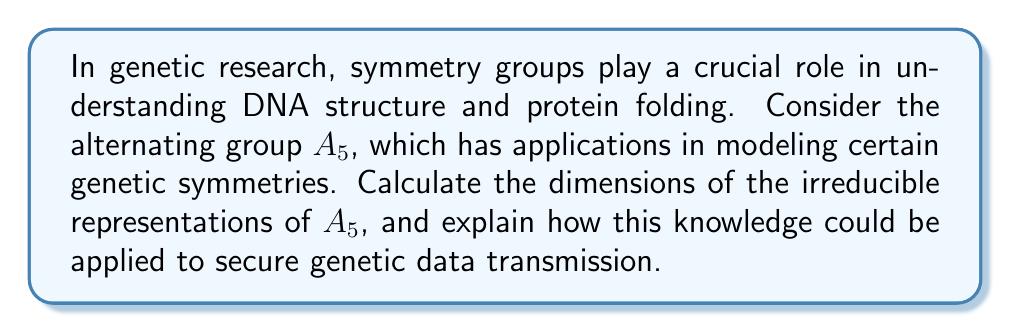Provide a solution to this math problem. To calculate the dimensions of the irreducible representations of $A_5$, we'll follow these steps:

1) First, recall that $A_5$ is the group of even permutations on 5 elements, with order $|A_5| = 60$.

2) The number of conjugacy classes in $A_5$ equals the number of irreducible representations. $A_5$ has 5 conjugacy classes:
   - Identity: $(1)$
   - 15 3-cycles: $(123)$
   - 20 3-cycles: $(132)$
   - 12 5-cycles: $(12345)$
   - 12 5-cycles: $(13524)$

3) Let's denote the dimensions of the irreducible representations as $d_1, d_2, d_3, d_4, d_5$.

4) We know that the sum of squares of dimensions equals the order of the group:

   $$d_1^2 + d_2^2 + d_3^2 + d_4^2 + d_5^2 = 60$$

5) The trivial representation always has dimension 1, so $d_1 = 1$.

6) $A_5$ is a simple group, so it has no non-trivial 1-dimensional representations.

7) The smallest non-trivial representation of $A_5$ has dimension 3 (this can be proved using character theory), so $d_2 = 3$.

8) $A_5$ is isomorphic to the group of rotational symmetries of an icosahedron, which has a natural 4-dimensional representation, so $d_3 = 4$.

9) Substituting the known values into the equation from step 4:

   $$1^2 + 3^2 + 4^2 + d_4^2 + d_5^2 = 60$$
   $$1 + 9 + 16 + d_4^2 + d_5^2 = 60$$
   $$d_4^2 + d_5^2 = 34$$

10) The only integer solution to this equation is $d_4 = 5$ and $d_5 = 3$.

Therefore, the dimensions of the irreducible representations of $A_5$ are 1, 3, 3, 4, and 5.

In terms of genetic data security, these dimensions could be used to design encryption schemes based on the structure of $A_5$. For example, genetic data could be encoded into matrices corresponding to these representations, making use of the group's symmetries to create complex, yet reversible, transformations of the data.
Answer: 1, 3, 3, 4, 5 